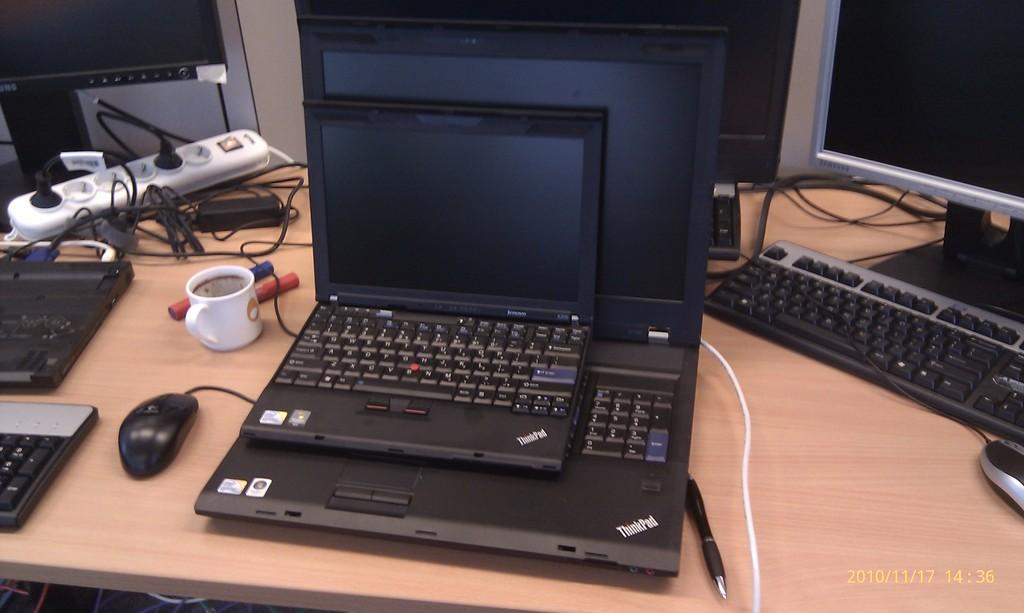<image>
Share a concise interpretation of the image provided. Computers on a desk, one is a large ThinkPad and a smaller one on top of it. 